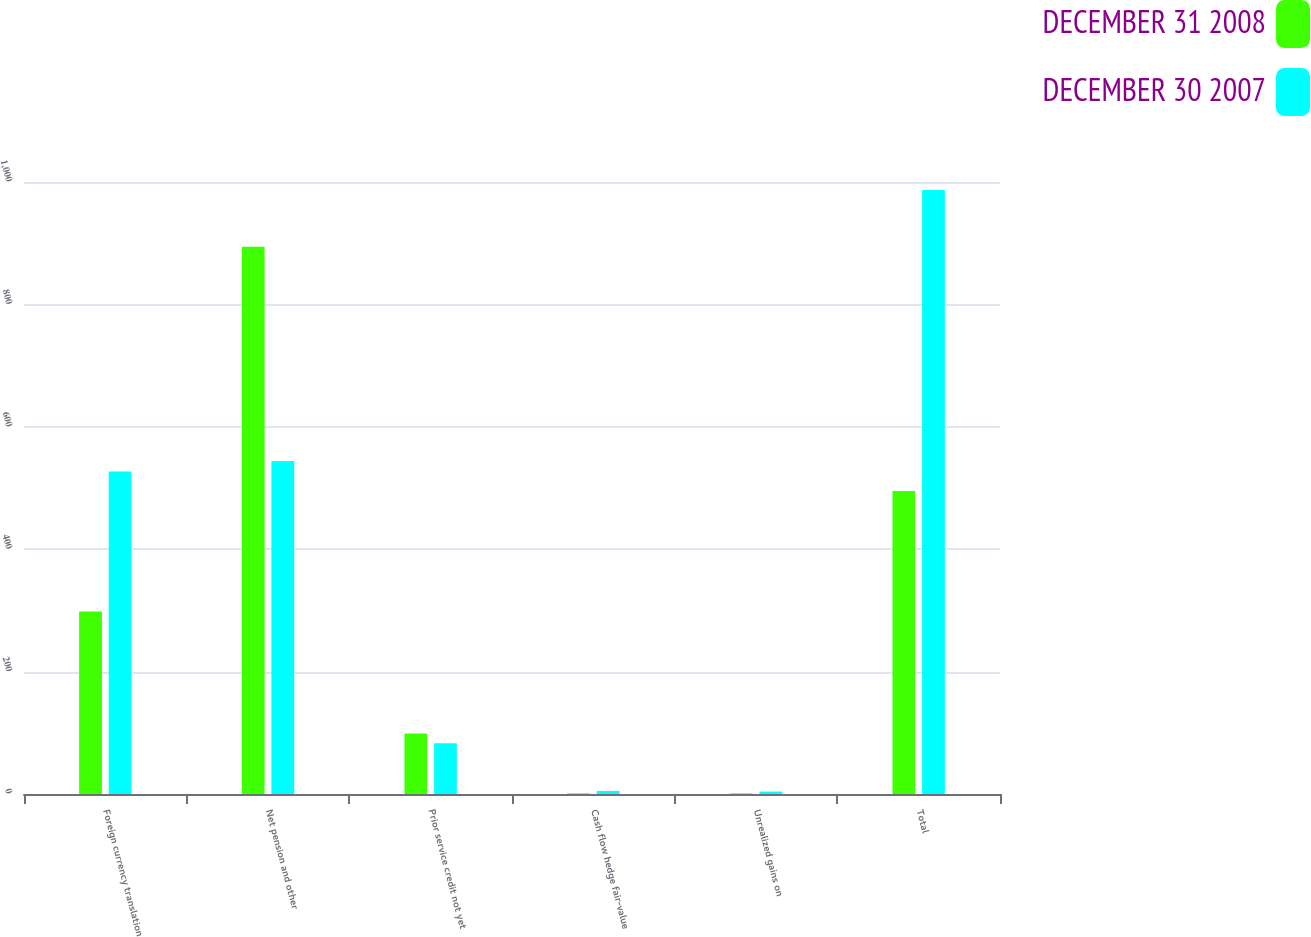<chart> <loc_0><loc_0><loc_500><loc_500><stacked_bar_chart><ecel><fcel>Foreign currency translation<fcel>Net pension and other<fcel>Prior service credit not yet<fcel>Cash flow hedge fair-value<fcel>Unrealized gains on<fcel>Total<nl><fcel>DECEMBER 31 2008<fcel>298<fcel>894<fcel>99<fcel>1<fcel>1<fcel>495<nl><fcel>DECEMBER 30 2007<fcel>527<fcel>544<fcel>83<fcel>5<fcel>4<fcel>987<nl></chart> 